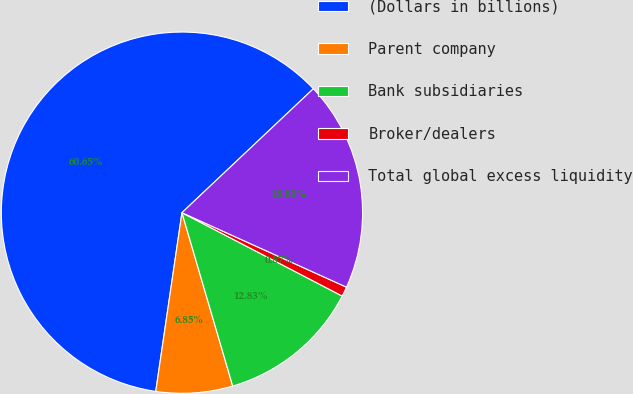<chart> <loc_0><loc_0><loc_500><loc_500><pie_chart><fcel>(Dollars in billions)<fcel>Parent company<fcel>Bank subsidiaries<fcel>Broker/dealers<fcel>Total global excess liquidity<nl><fcel>60.64%<fcel>6.85%<fcel>12.83%<fcel>0.87%<fcel>18.8%<nl></chart> 